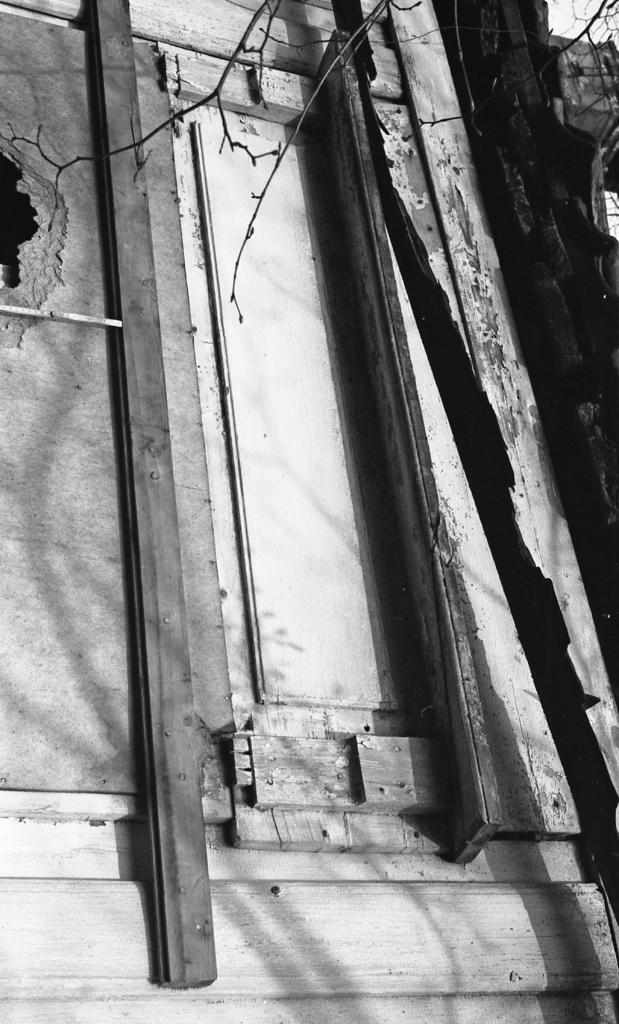What is the color scheme of the image? The image is black and white. What type of door can be seen in the image? There is a wooden door in the image. What other objects or features are present in the image? Branches are present in the image. How many pins are attached to the board in the image? There is no board or pins present in the image. What type of growth can be observed on the branches in the image? There are no visible growths on the branches in the image. 